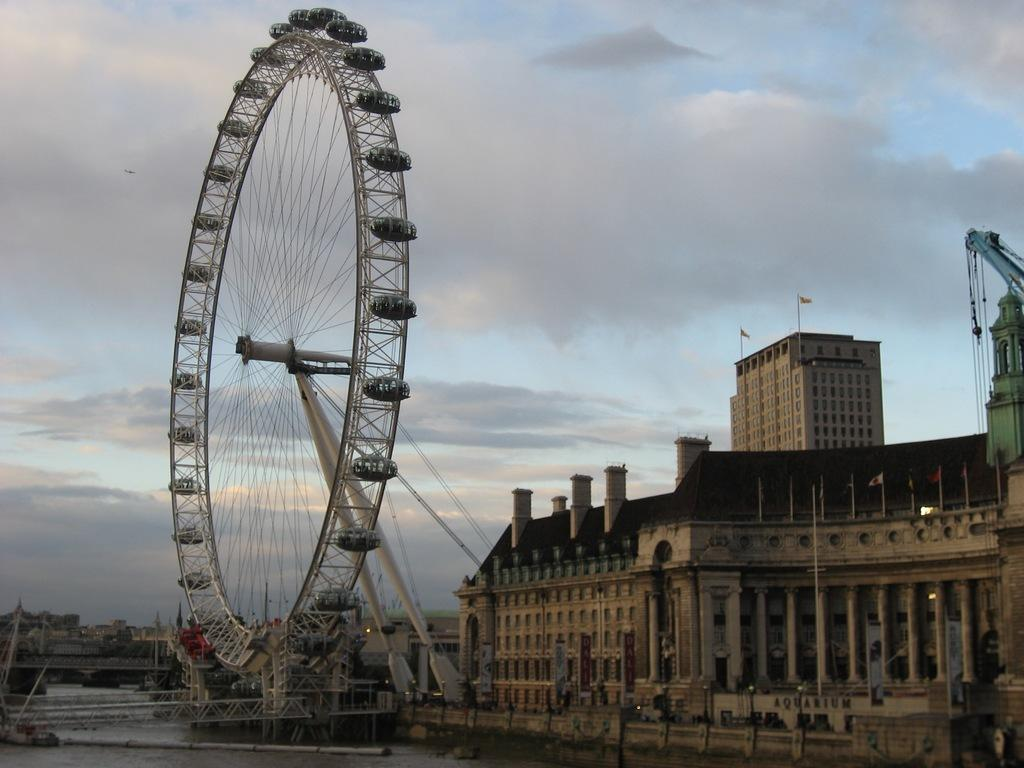What famous landmark can be seen in the image? The London Eye is visible in the image. What type of infrastructure is present in the image? There is a road in the image. What natural element is present in the image? There is water in the image. What type of structures can be seen on the right side of the image? There are buildings on the right side of the image. What is the condition of the sky in the image? The sky is cloudy and visible at the top of the image. Can you see any plants growing on the London Eye in the image? There are no plants growing on the London Eye in the image. Are there any icicles hanging from the buildings in the image? There are no icicles visible in the image. 